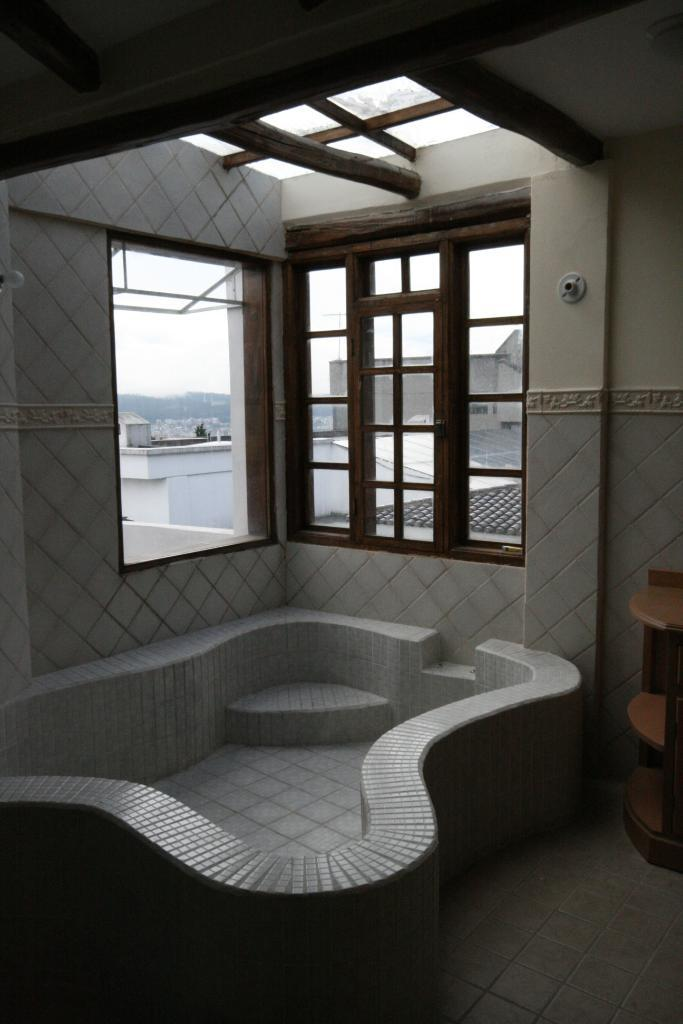What is the main object in the image? There is a table in the image. What can be seen through the windows in the image? Buildings are visible in the image through the windows. Where is the image taken from? The image is taken from inside a room. How many pigs are sitting on the table in the image? There are no pigs present in the image; the table is empty. What type of cactus can be seen growing near the windows in the image? There is no cactus visible in the image; only buildings can be seen through the windows. 